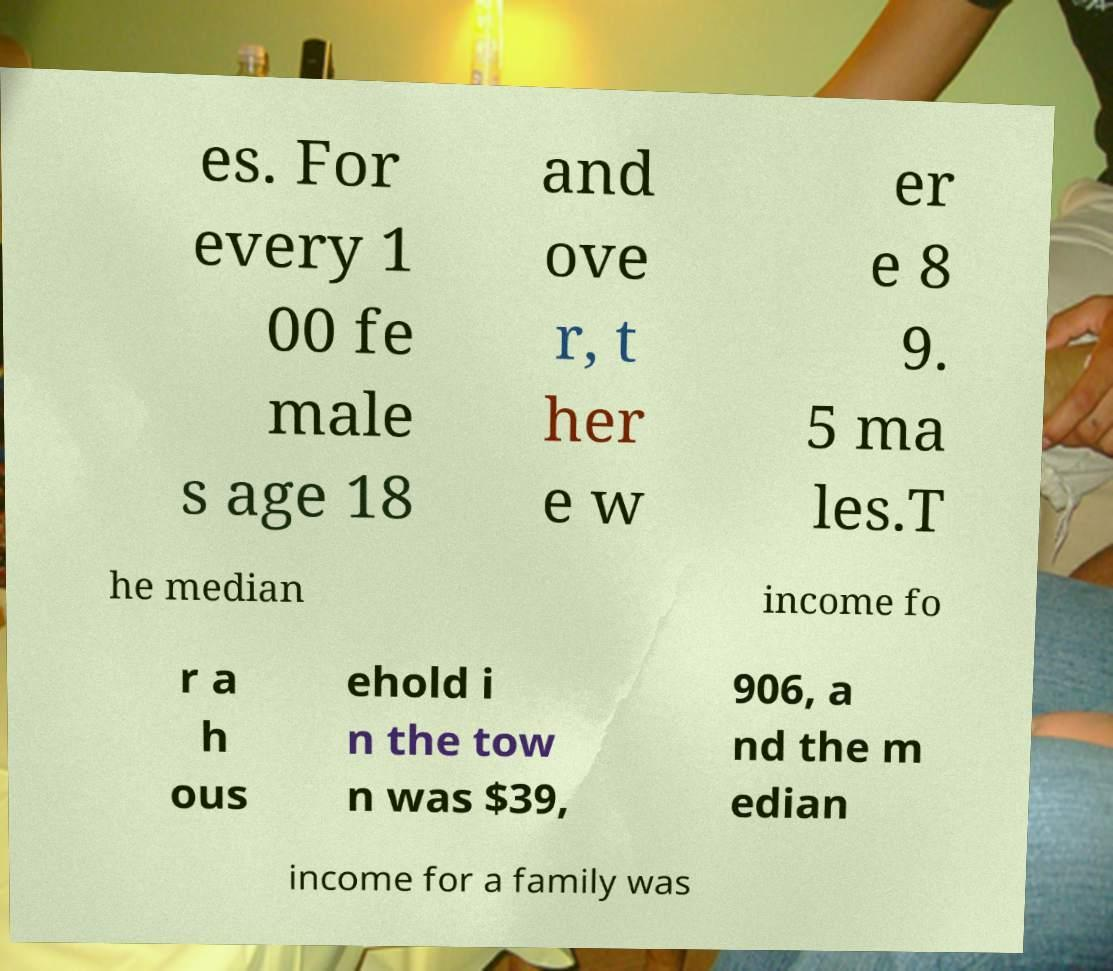Could you extract and type out the text from this image? es. For every 1 00 fe male s age 18 and ove r, t her e w er e 8 9. 5 ma les.T he median income fo r a h ous ehold i n the tow n was $39, 906, a nd the m edian income for a family was 